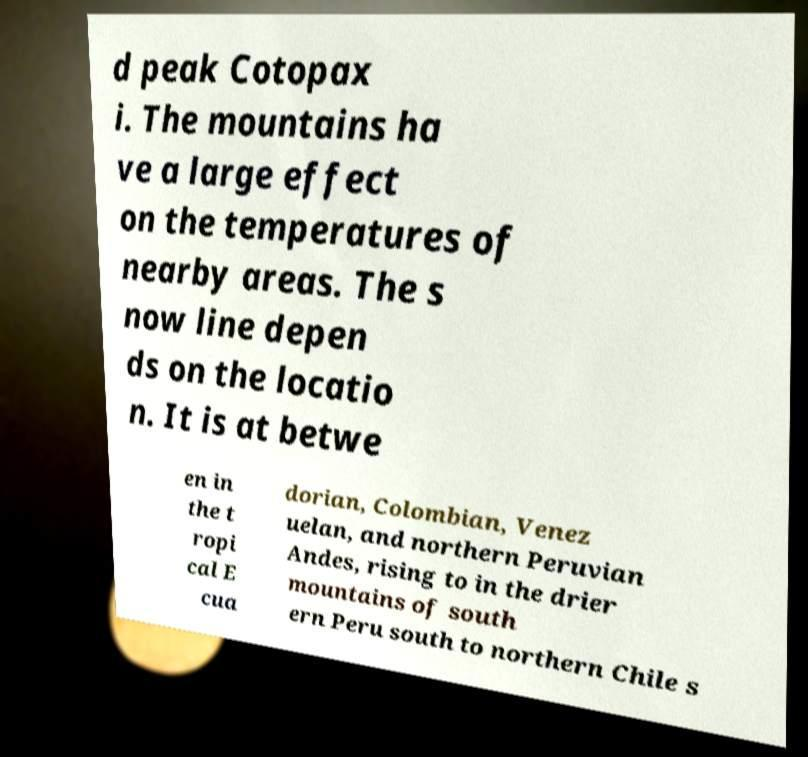Please identify and transcribe the text found in this image. d peak Cotopax i. The mountains ha ve a large effect on the temperatures of nearby areas. The s now line depen ds on the locatio n. It is at betwe en in the t ropi cal E cua dorian, Colombian, Venez uelan, and northern Peruvian Andes, rising to in the drier mountains of south ern Peru south to northern Chile s 